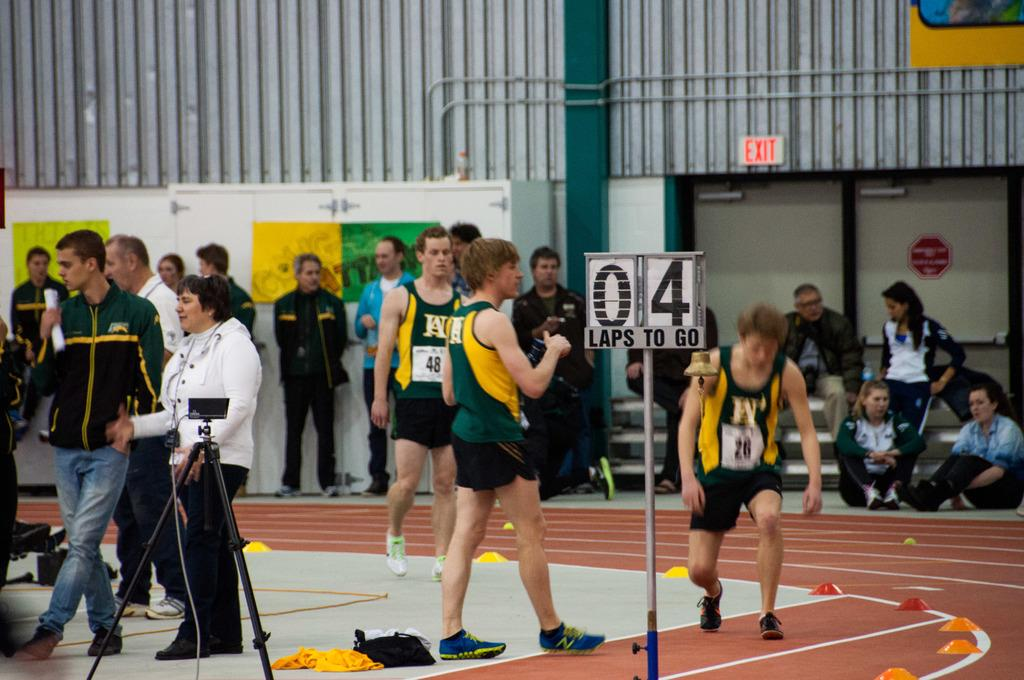<image>
Describe the image concisely. People racing on a track with a sign that says there are 4 laps to go. 